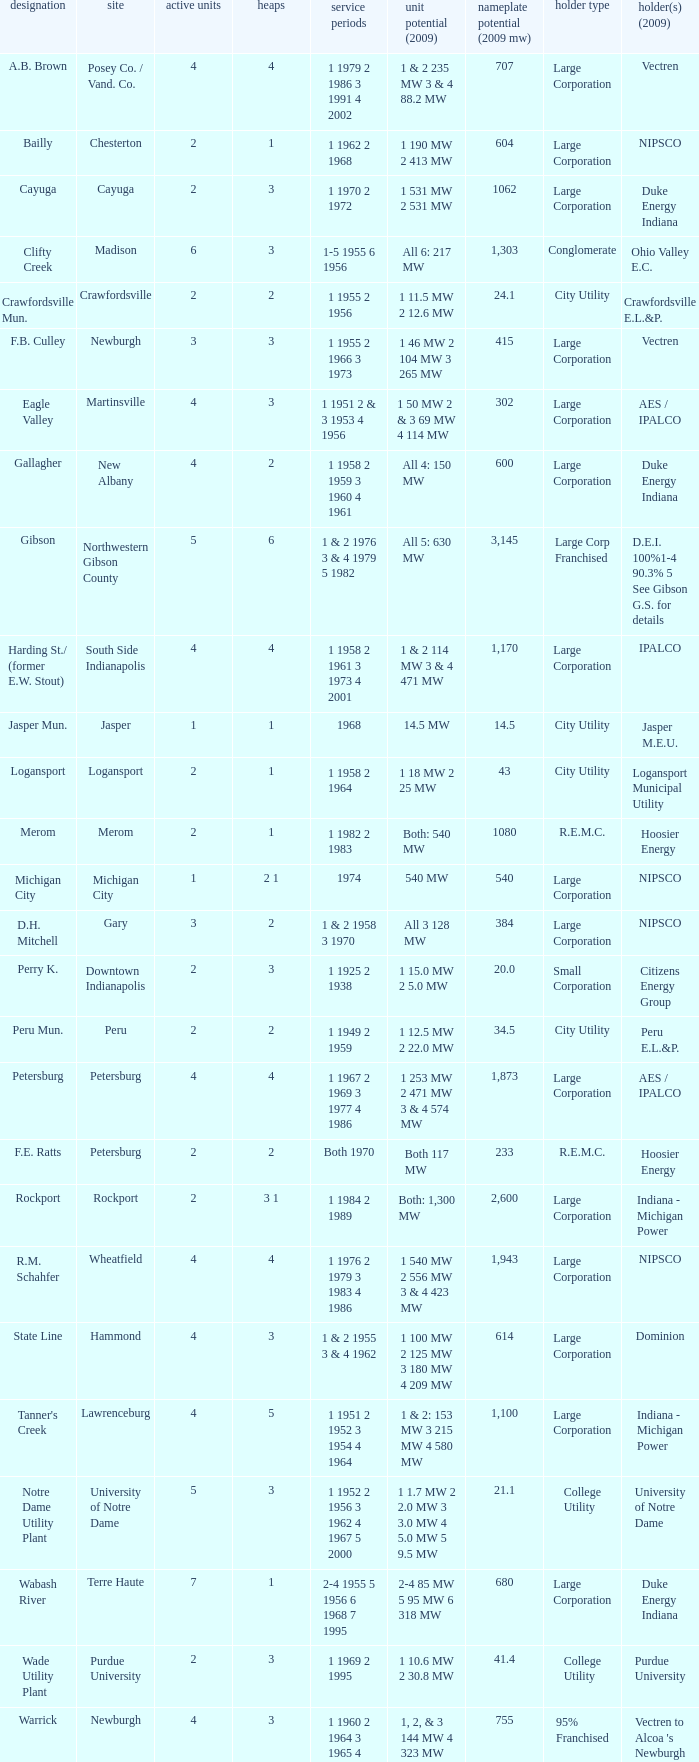Name the number for service dates for hoosier energy for petersburg 1.0. 